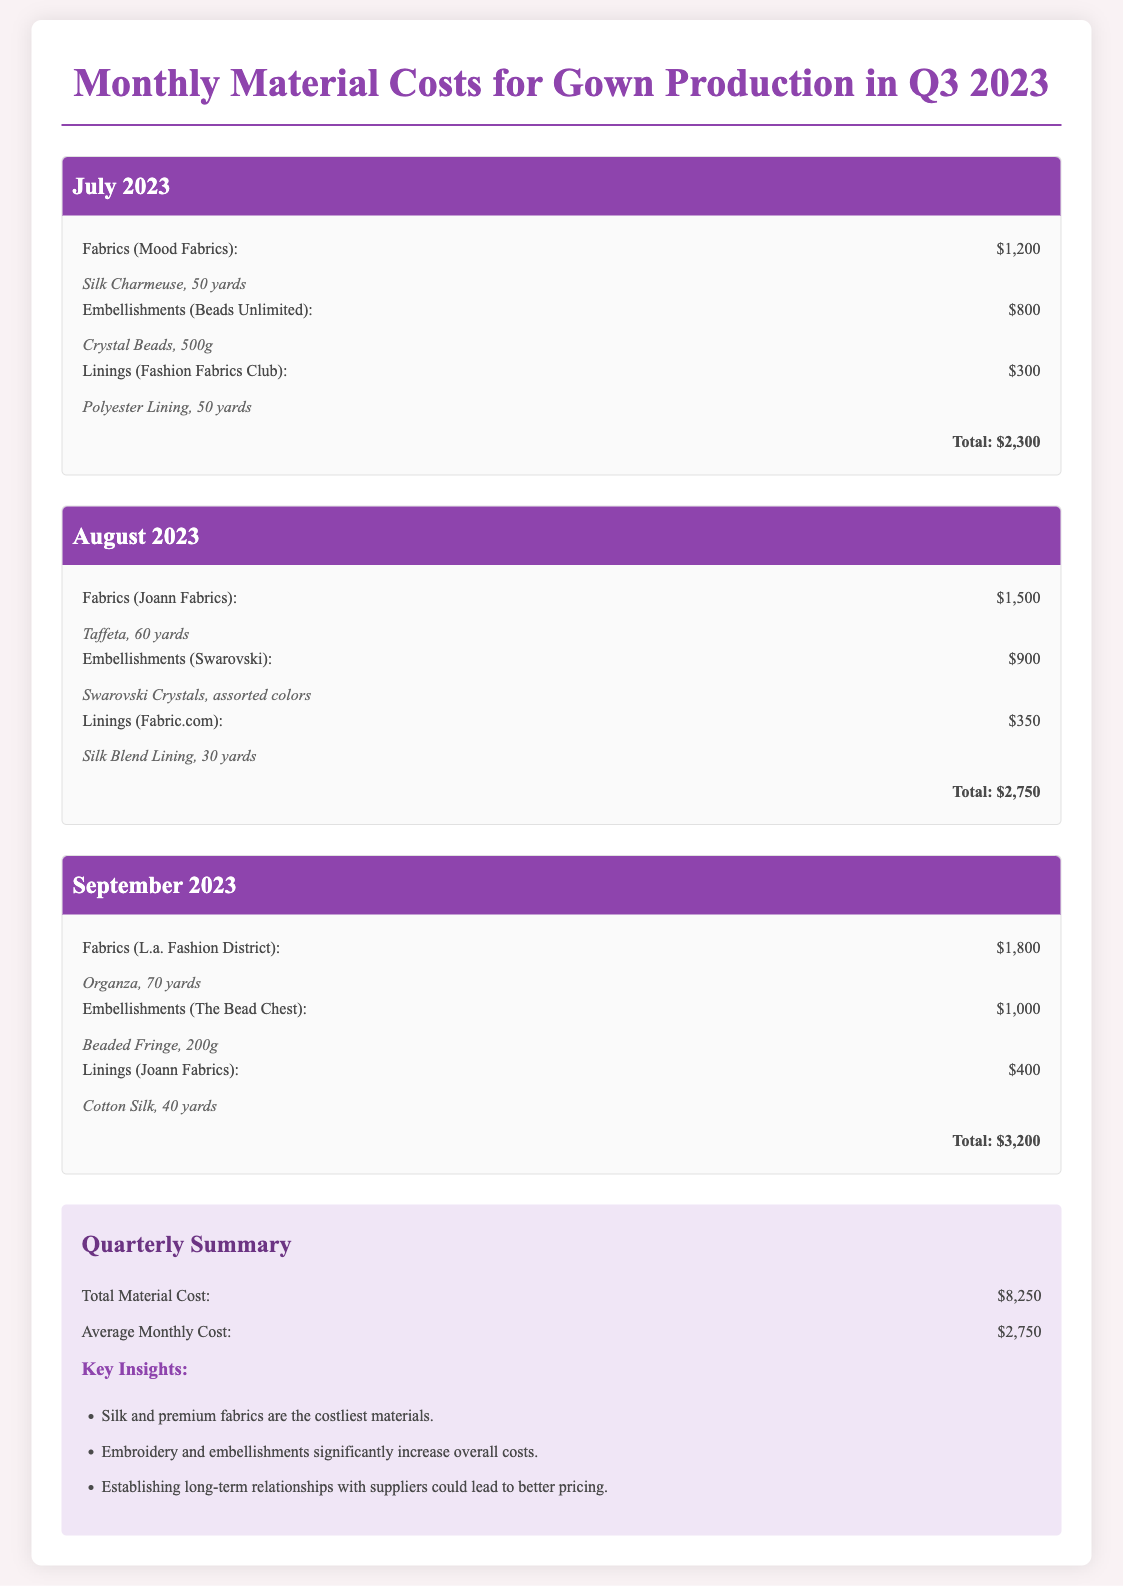What was the total material cost for July 2023? The total material cost for July is provided in the document as a summary for that month.
Answer: $2,300 Which supplier provided the most expensive fabrics in August 2023? The document lists the cost of fabrics along with the corresponding suppliers for August, identifying Joann Fabrics as the most expensive.
Answer: Joann Fabrics How many yards of Organza were purchased in September 2023? The document specifies the quantity of Organza purchased for September.
Answer: 70 yards What is the average monthly material cost for Q3 2023? The average monthly cost can be calculated from the quarterly total by dividing it by three months.
Answer: $2,750 Which month had the highest total material cost? The total material cost for each month is presented, with September having the highest total.
Answer: September 2023 What type of embellishments were purchased in July 2023? The document specifies the type of embellishments purchased for July, which were Crystal Beads.
Answer: Crystal Beads What is the total expenditure on linings across all months? The total spent on linings is calculated by adding up the linings from each month as detailed in the document.
Answer: $1,050 Which month had the lowest total material cost? By comparing the total costs for each month listed in the document, it is determined that July had the lowest cost.
Answer: July 2023 What are the key insights listed in the quarterly summary? The document includes specific insights regarding material costs, such as the importance of silk fabrics and establishing supplier relationships.
Answer: Silk and premium fabrics are the costliest materials 